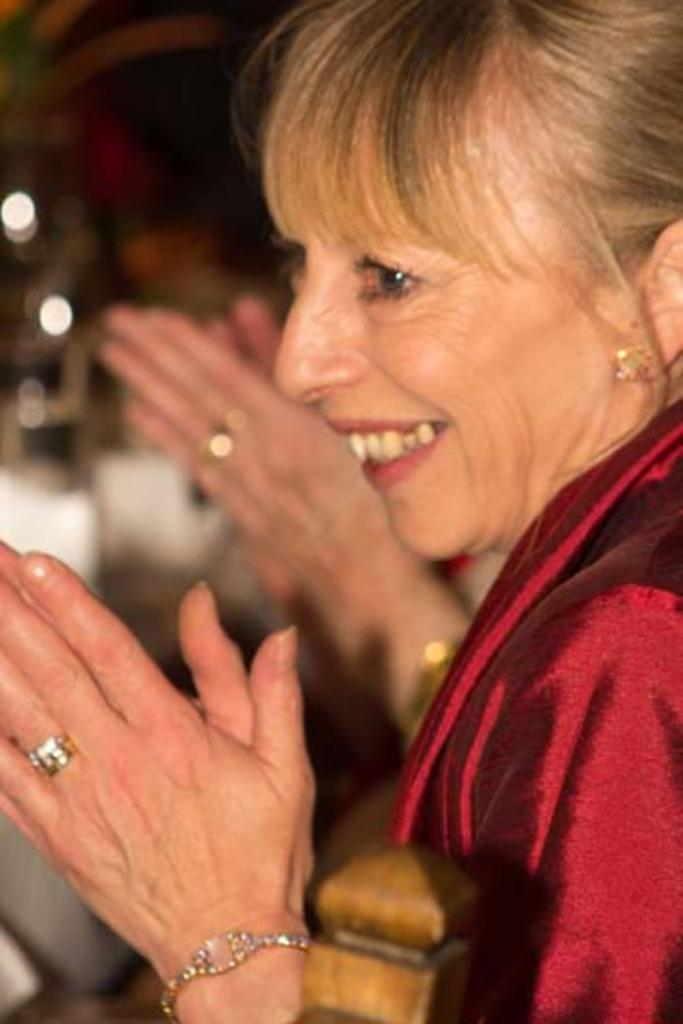Who is the main subject in the image? There is a woman in the image. What is the woman doing in the image? The woman is clapping. Can you describe any other visible body parts in the image? There is a human hand visible behind the woman. What type of alley can be seen in the background of the image? There is no alley visible in the image; it only features a woman clapping and a human hand behind her. 